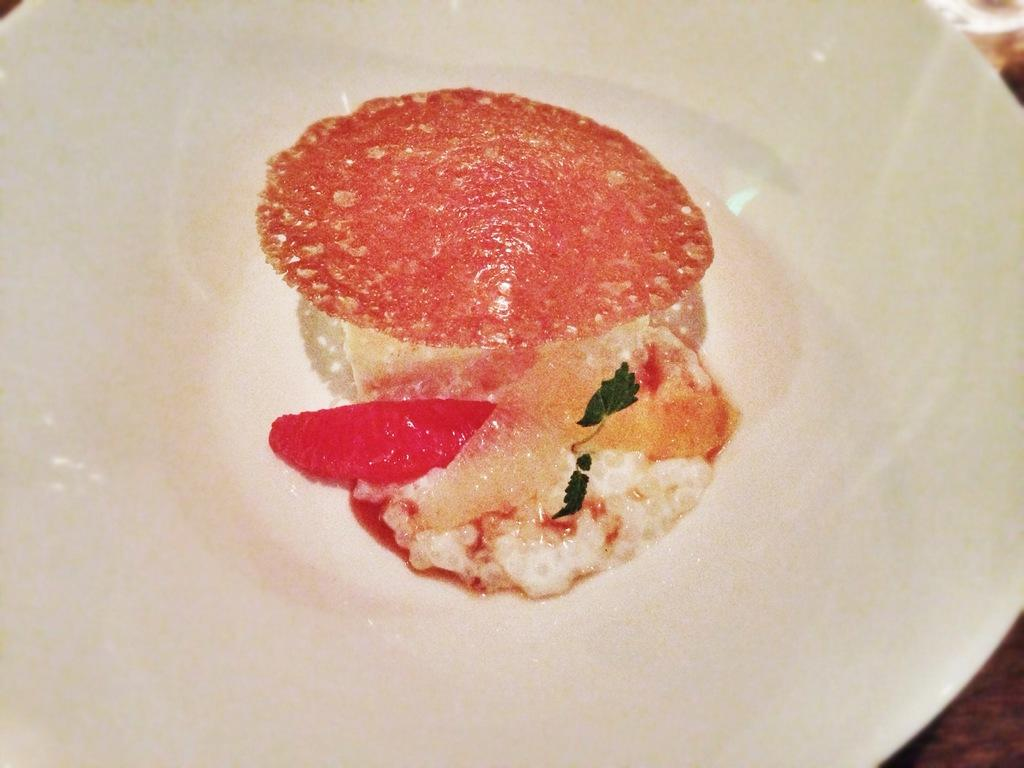What is the color of the plate in the image? The plate in the image is white. Where is the plate located? The plate is on an object. What is on the plate? There are food items on the plate. What type of cloud is visible above the plate in the image? There is no cloud visible in the image; it only shows a white plate with food items on it. 